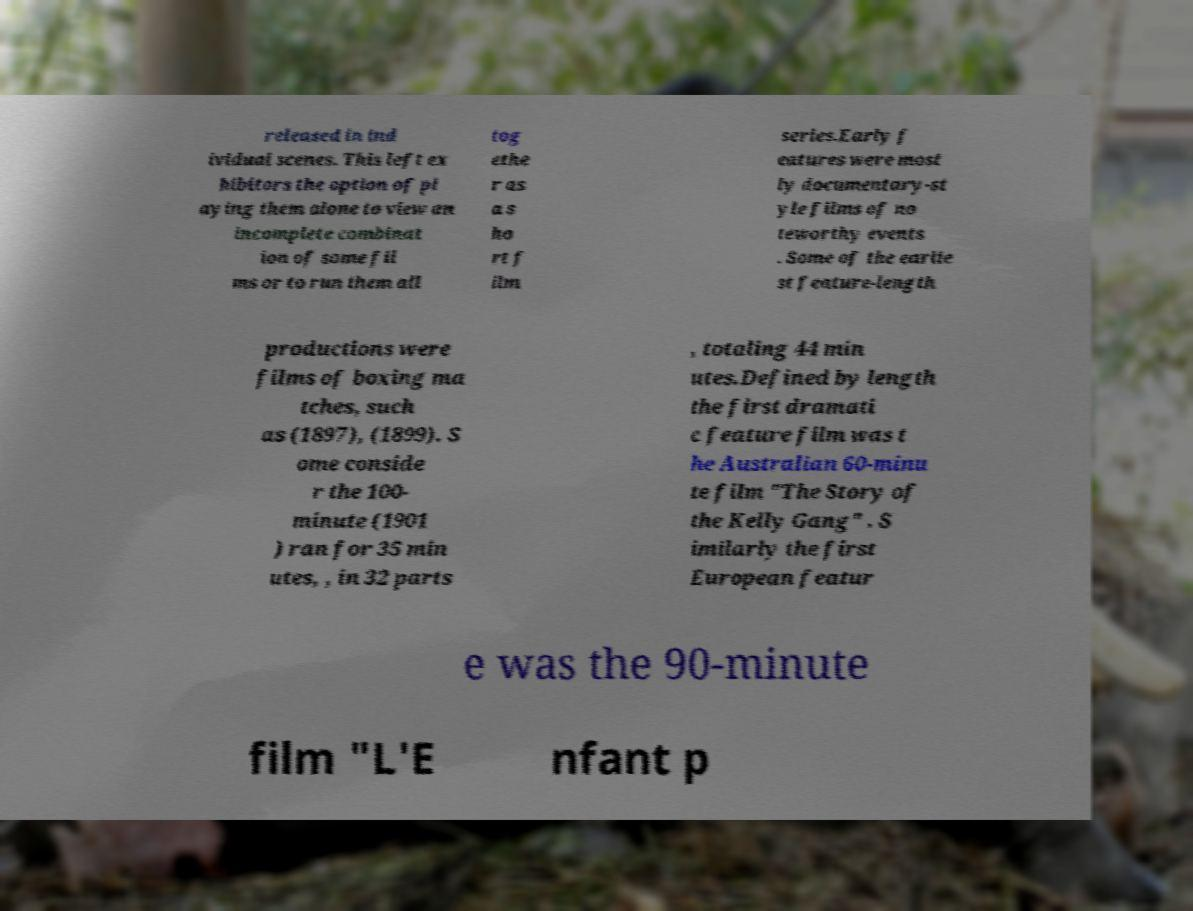What messages or text are displayed in this image? I need them in a readable, typed format. released in ind ividual scenes. This left ex hibitors the option of pl aying them alone to view an incomplete combinat ion of some fil ms or to run them all tog ethe r as a s ho rt f ilm series.Early f eatures were most ly documentary-st yle films of no teworthy events . Some of the earlie st feature-length productions were films of boxing ma tches, such as (1897), (1899). S ome conside r the 100- minute (1901 ) ran for 35 min utes, , in 32 parts , totaling 44 min utes.Defined by length the first dramati c feature film was t he Australian 60-minu te film "The Story of the Kelly Gang" . S imilarly the first European featur e was the 90-minute film "L'E nfant p 